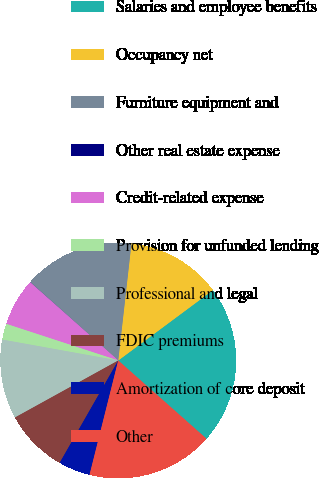Convert chart. <chart><loc_0><loc_0><loc_500><loc_500><pie_chart><fcel>Salaries and employee benefits<fcel>Occupancy net<fcel>Furniture equipment and<fcel>Other real estate expense<fcel>Credit-related expense<fcel>Provision for unfunded lending<fcel>Professional and legal<fcel>FDIC premiums<fcel>Amortization of core deposit<fcel>Other<nl><fcel>21.71%<fcel>13.04%<fcel>15.21%<fcel>0.02%<fcel>6.53%<fcel>2.19%<fcel>10.87%<fcel>8.7%<fcel>4.36%<fcel>17.37%<nl></chart> 